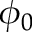<formula> <loc_0><loc_0><loc_500><loc_500>\phi _ { 0 }</formula> 